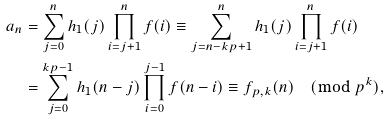<formula> <loc_0><loc_0><loc_500><loc_500>a _ { n } & = \sum _ { j = 0 } ^ { n } h _ { 1 } ( j ) \prod _ { i = j + 1 } ^ { n } f ( i ) \equiv \sum _ { j = n - k p + 1 } ^ { n } h _ { 1 } ( j ) \prod _ { i = j + 1 } ^ { n } f ( i ) \\ & = \sum _ { j = 0 } ^ { k p - 1 } h _ { 1 } ( n - j ) \prod _ { i = 0 } ^ { j - 1 } f ( n - i ) \equiv f _ { p , k } ( n ) \pmod { p ^ { k } } ,</formula> 